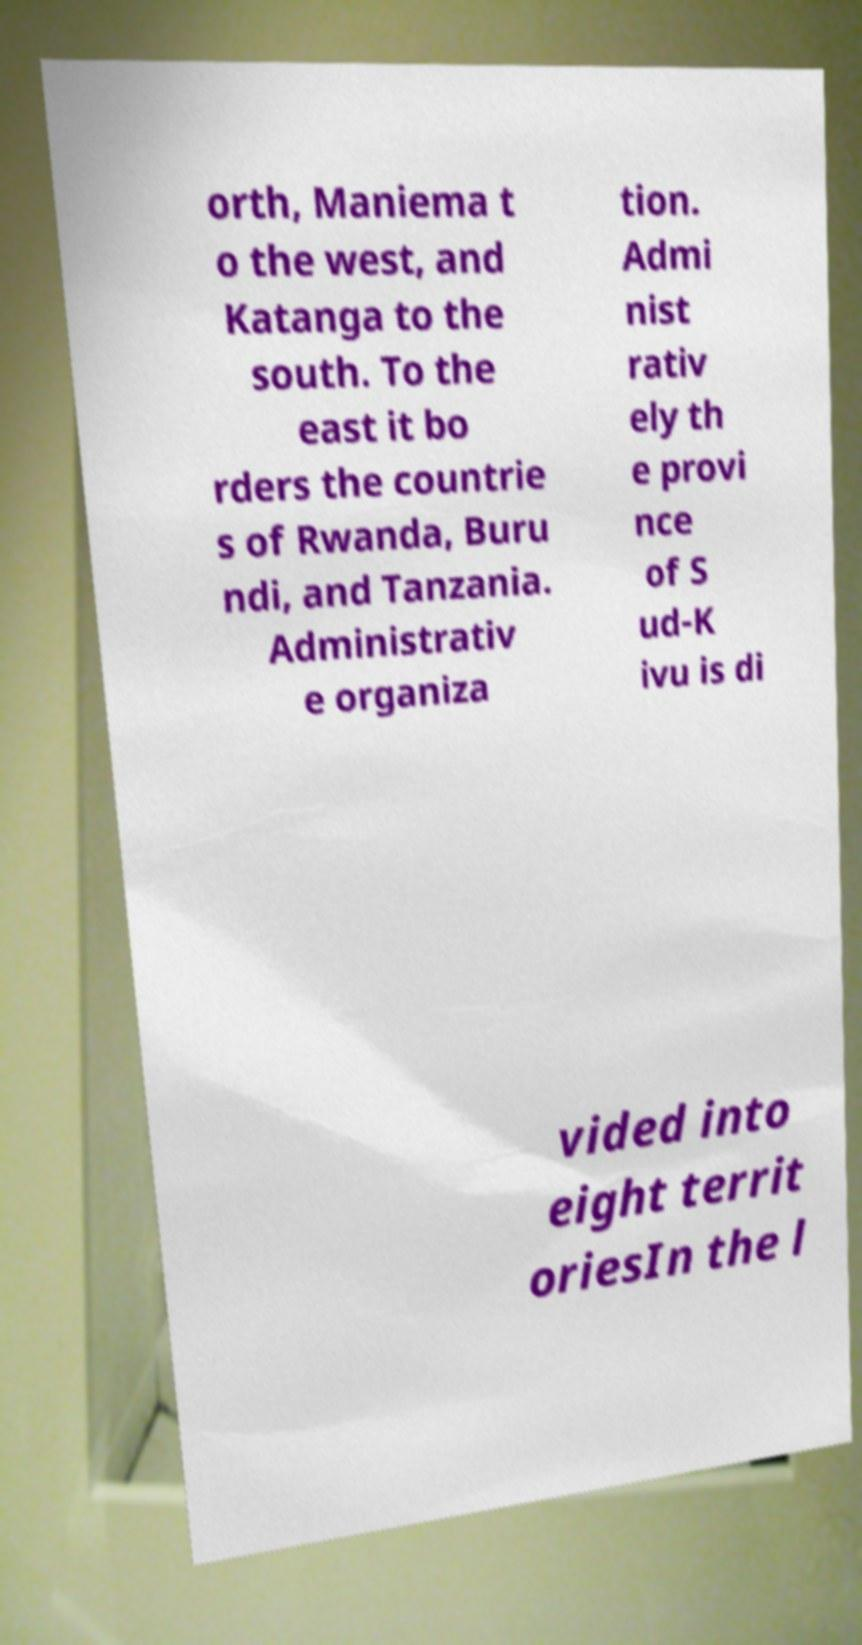Please read and relay the text visible in this image. What does it say? orth, Maniema t o the west, and Katanga to the south. To the east it bo rders the countrie s of Rwanda, Buru ndi, and Tanzania. Administrativ e organiza tion. Admi nist rativ ely th e provi nce of S ud-K ivu is di vided into eight territ oriesIn the l 